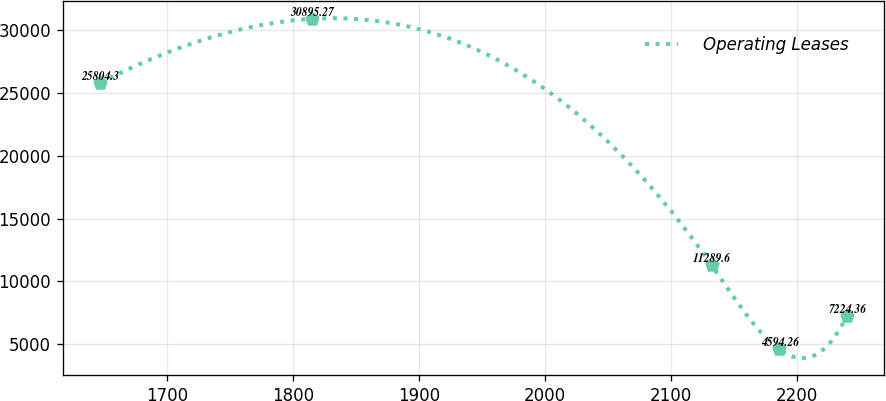Convert chart. <chart><loc_0><loc_0><loc_500><loc_500><line_chart><ecel><fcel>Operating Leases<nl><fcel>1646.94<fcel>25804.3<nl><fcel>1814.75<fcel>30895.3<nl><fcel>2132.05<fcel>11289.6<nl><fcel>2185.57<fcel>4594.26<nl><fcel>2239.09<fcel>7224.36<nl></chart> 